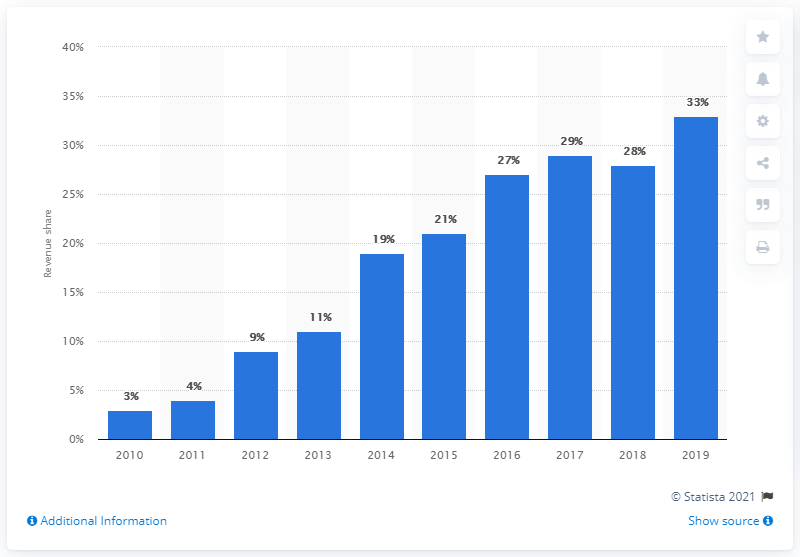Identify some key points in this picture. In 2019, the percentage of revenue generated by downloads from PC and console games sales in Germany was 33%. 